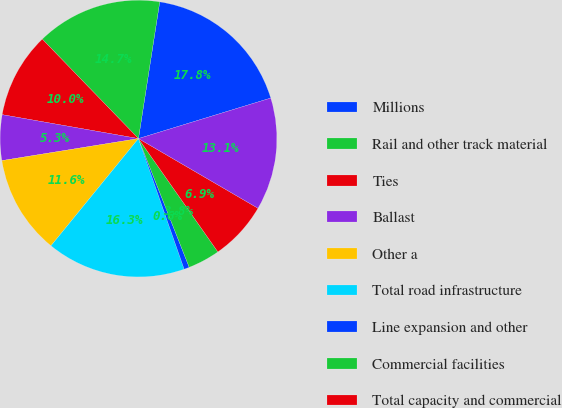Convert chart. <chart><loc_0><loc_0><loc_500><loc_500><pie_chart><fcel>Millions<fcel>Rail and other track material<fcel>Ties<fcel>Ballast<fcel>Other a<fcel>Total road infrastructure<fcel>Line expansion and other<fcel>Commercial facilities<fcel>Total capacity and commercial<fcel>Locomotives and freight cars b<nl><fcel>17.81%<fcel>14.69%<fcel>10.0%<fcel>5.31%<fcel>11.56%<fcel>16.25%<fcel>0.62%<fcel>3.75%<fcel>6.87%<fcel>13.13%<nl></chart> 